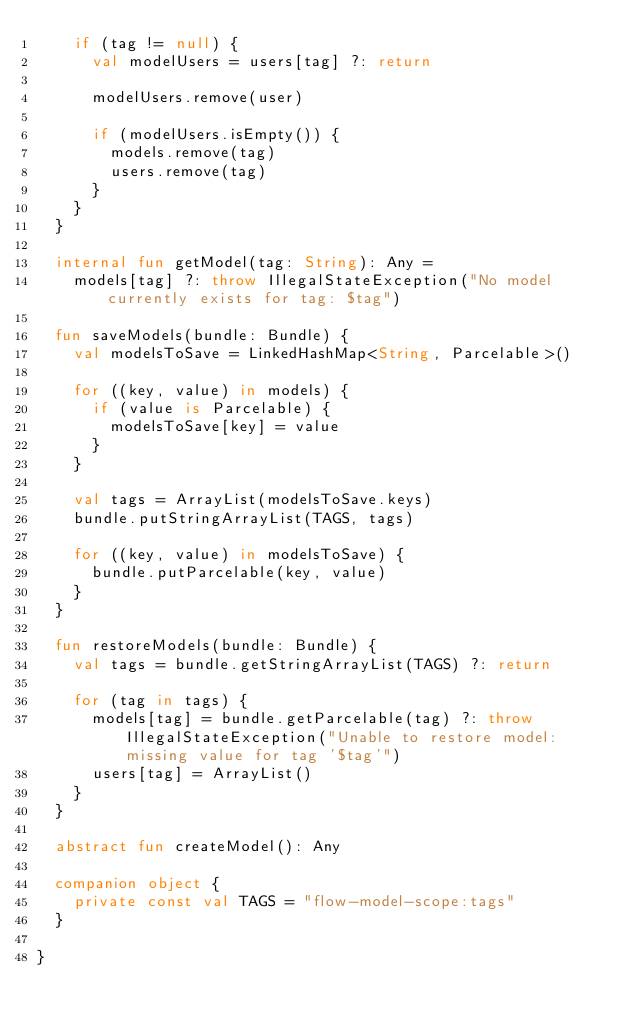Convert code to text. <code><loc_0><loc_0><loc_500><loc_500><_Kotlin_>    if (tag != null) {
      val modelUsers = users[tag] ?: return

      modelUsers.remove(user)

      if (modelUsers.isEmpty()) {
        models.remove(tag)
        users.remove(tag)
      }
    }
  }

  internal fun getModel(tag: String): Any =
    models[tag] ?: throw IllegalStateException("No model currently exists for tag: $tag")

  fun saveModels(bundle: Bundle) {
    val modelsToSave = LinkedHashMap<String, Parcelable>()

    for ((key, value) in models) {
      if (value is Parcelable) {
        modelsToSave[key] = value
      }
    }

    val tags = ArrayList(modelsToSave.keys)
    bundle.putStringArrayList(TAGS, tags)

    for ((key, value) in modelsToSave) {
      bundle.putParcelable(key, value)
    }
  }

  fun restoreModels(bundle: Bundle) {
    val tags = bundle.getStringArrayList(TAGS) ?: return

    for (tag in tags) {
      models[tag] = bundle.getParcelable(tag) ?: throw IllegalStateException("Unable to restore model: missing value for tag '$tag'")
      users[tag] = ArrayList()
    }
  }

  abstract fun createModel(): Any

  companion object {
    private const val TAGS = "flow-model-scope:tags"
  }

}</code> 